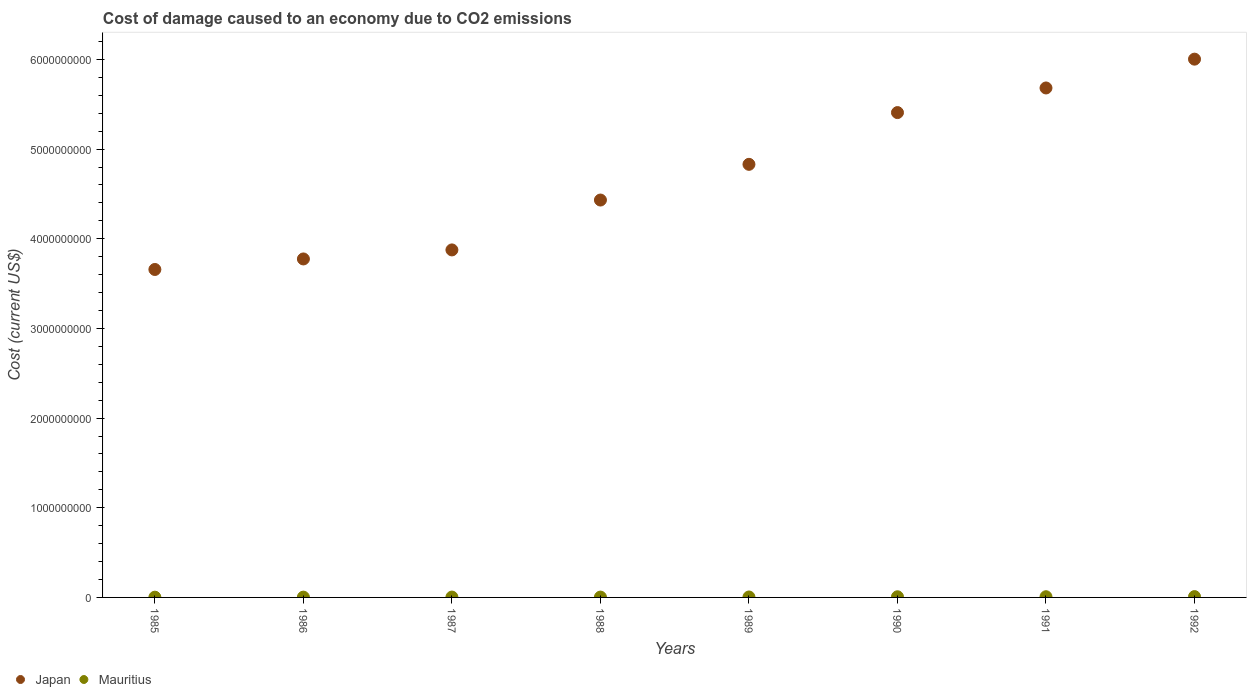How many different coloured dotlines are there?
Offer a very short reply. 2. Is the number of dotlines equal to the number of legend labels?
Your answer should be very brief. Yes. What is the cost of damage caused due to CO2 emissisons in Japan in 1990?
Give a very brief answer. 5.41e+09. Across all years, what is the maximum cost of damage caused due to CO2 emissisons in Japan?
Your response must be concise. 6.00e+09. Across all years, what is the minimum cost of damage caused due to CO2 emissisons in Japan?
Your answer should be very brief. 3.66e+09. In which year was the cost of damage caused due to CO2 emissisons in Japan minimum?
Provide a succinct answer. 1985. What is the total cost of damage caused due to CO2 emissisons in Japan in the graph?
Ensure brevity in your answer.  3.77e+1. What is the difference between the cost of damage caused due to CO2 emissisons in Japan in 1988 and that in 1991?
Provide a succinct answer. -1.25e+09. What is the difference between the cost of damage caused due to CO2 emissisons in Mauritius in 1992 and the cost of damage caused due to CO2 emissisons in Japan in 1990?
Your answer should be very brief. -5.40e+09. What is the average cost of damage caused due to CO2 emissisons in Mauritius per year?
Offer a terse response. 5.39e+06. In the year 1987, what is the difference between the cost of damage caused due to CO2 emissisons in Japan and cost of damage caused due to CO2 emissisons in Mauritius?
Keep it short and to the point. 3.87e+09. What is the ratio of the cost of damage caused due to CO2 emissisons in Mauritius in 1991 to that in 1992?
Your answer should be compact. 0.86. Is the cost of damage caused due to CO2 emissisons in Mauritius in 1988 less than that in 1991?
Ensure brevity in your answer.  Yes. What is the difference between the highest and the second highest cost of damage caused due to CO2 emissisons in Mauritius?
Offer a terse response. 1.27e+06. What is the difference between the highest and the lowest cost of damage caused due to CO2 emissisons in Japan?
Give a very brief answer. 2.35e+09. Is the sum of the cost of damage caused due to CO2 emissisons in Japan in 1987 and 1990 greater than the maximum cost of damage caused due to CO2 emissisons in Mauritius across all years?
Your response must be concise. Yes. Is the cost of damage caused due to CO2 emissisons in Mauritius strictly greater than the cost of damage caused due to CO2 emissisons in Japan over the years?
Your response must be concise. No. Are the values on the major ticks of Y-axis written in scientific E-notation?
Your answer should be compact. No. Does the graph contain grids?
Your answer should be very brief. No. Where does the legend appear in the graph?
Provide a short and direct response. Bottom left. What is the title of the graph?
Keep it short and to the point. Cost of damage caused to an economy due to CO2 emissions. Does "Latin America(developing only)" appear as one of the legend labels in the graph?
Your answer should be very brief. No. What is the label or title of the Y-axis?
Your response must be concise. Cost (current US$). What is the Cost (current US$) of Japan in 1985?
Provide a short and direct response. 3.66e+09. What is the Cost (current US$) of Mauritius in 1985?
Keep it short and to the point. 2.83e+06. What is the Cost (current US$) of Japan in 1986?
Ensure brevity in your answer.  3.77e+09. What is the Cost (current US$) in Mauritius in 1986?
Give a very brief answer. 3.30e+06. What is the Cost (current US$) of Japan in 1987?
Provide a succinct answer. 3.88e+09. What is the Cost (current US$) in Mauritius in 1987?
Offer a very short reply. 3.99e+06. What is the Cost (current US$) of Japan in 1988?
Provide a succinct answer. 4.43e+09. What is the Cost (current US$) of Mauritius in 1988?
Give a very brief answer. 3.83e+06. What is the Cost (current US$) in Japan in 1989?
Provide a short and direct response. 4.83e+09. What is the Cost (current US$) of Mauritius in 1989?
Make the answer very short. 4.96e+06. What is the Cost (current US$) in Japan in 1990?
Ensure brevity in your answer.  5.41e+09. What is the Cost (current US$) of Mauritius in 1990?
Keep it short and to the point. 7.23e+06. What is the Cost (current US$) in Japan in 1991?
Your answer should be very brief. 5.68e+09. What is the Cost (current US$) of Mauritius in 1991?
Your answer should be very brief. 7.86e+06. What is the Cost (current US$) of Japan in 1992?
Offer a very short reply. 6.00e+09. What is the Cost (current US$) in Mauritius in 1992?
Make the answer very short. 9.13e+06. Across all years, what is the maximum Cost (current US$) in Japan?
Your answer should be compact. 6.00e+09. Across all years, what is the maximum Cost (current US$) of Mauritius?
Offer a terse response. 9.13e+06. Across all years, what is the minimum Cost (current US$) of Japan?
Offer a very short reply. 3.66e+09. Across all years, what is the minimum Cost (current US$) in Mauritius?
Ensure brevity in your answer.  2.83e+06. What is the total Cost (current US$) of Japan in the graph?
Provide a short and direct response. 3.77e+1. What is the total Cost (current US$) of Mauritius in the graph?
Your answer should be compact. 4.31e+07. What is the difference between the Cost (current US$) of Japan in 1985 and that in 1986?
Your answer should be very brief. -1.17e+08. What is the difference between the Cost (current US$) in Mauritius in 1985 and that in 1986?
Ensure brevity in your answer.  -4.69e+05. What is the difference between the Cost (current US$) of Japan in 1985 and that in 1987?
Offer a very short reply. -2.18e+08. What is the difference between the Cost (current US$) of Mauritius in 1985 and that in 1987?
Give a very brief answer. -1.16e+06. What is the difference between the Cost (current US$) of Japan in 1985 and that in 1988?
Your response must be concise. -7.74e+08. What is the difference between the Cost (current US$) in Mauritius in 1985 and that in 1988?
Offer a terse response. -1.00e+06. What is the difference between the Cost (current US$) of Japan in 1985 and that in 1989?
Keep it short and to the point. -1.17e+09. What is the difference between the Cost (current US$) in Mauritius in 1985 and that in 1989?
Ensure brevity in your answer.  -2.13e+06. What is the difference between the Cost (current US$) of Japan in 1985 and that in 1990?
Your answer should be very brief. -1.75e+09. What is the difference between the Cost (current US$) of Mauritius in 1985 and that in 1990?
Provide a succinct answer. -4.40e+06. What is the difference between the Cost (current US$) of Japan in 1985 and that in 1991?
Give a very brief answer. -2.02e+09. What is the difference between the Cost (current US$) of Mauritius in 1985 and that in 1991?
Keep it short and to the point. -5.03e+06. What is the difference between the Cost (current US$) of Japan in 1985 and that in 1992?
Offer a very short reply. -2.35e+09. What is the difference between the Cost (current US$) in Mauritius in 1985 and that in 1992?
Offer a very short reply. -6.31e+06. What is the difference between the Cost (current US$) in Japan in 1986 and that in 1987?
Keep it short and to the point. -1.01e+08. What is the difference between the Cost (current US$) of Mauritius in 1986 and that in 1987?
Offer a very short reply. -6.89e+05. What is the difference between the Cost (current US$) in Japan in 1986 and that in 1988?
Your answer should be compact. -6.57e+08. What is the difference between the Cost (current US$) in Mauritius in 1986 and that in 1988?
Your response must be concise. -5.32e+05. What is the difference between the Cost (current US$) in Japan in 1986 and that in 1989?
Provide a short and direct response. -1.06e+09. What is the difference between the Cost (current US$) in Mauritius in 1986 and that in 1989?
Give a very brief answer. -1.66e+06. What is the difference between the Cost (current US$) of Japan in 1986 and that in 1990?
Offer a terse response. -1.63e+09. What is the difference between the Cost (current US$) in Mauritius in 1986 and that in 1990?
Provide a succinct answer. -3.93e+06. What is the difference between the Cost (current US$) in Japan in 1986 and that in 1991?
Your answer should be compact. -1.91e+09. What is the difference between the Cost (current US$) of Mauritius in 1986 and that in 1991?
Make the answer very short. -4.56e+06. What is the difference between the Cost (current US$) of Japan in 1986 and that in 1992?
Keep it short and to the point. -2.23e+09. What is the difference between the Cost (current US$) in Mauritius in 1986 and that in 1992?
Keep it short and to the point. -5.84e+06. What is the difference between the Cost (current US$) of Japan in 1987 and that in 1988?
Your response must be concise. -5.56e+08. What is the difference between the Cost (current US$) of Mauritius in 1987 and that in 1988?
Your answer should be compact. 1.57e+05. What is the difference between the Cost (current US$) of Japan in 1987 and that in 1989?
Provide a short and direct response. -9.54e+08. What is the difference between the Cost (current US$) of Mauritius in 1987 and that in 1989?
Offer a terse response. -9.71e+05. What is the difference between the Cost (current US$) of Japan in 1987 and that in 1990?
Your answer should be compact. -1.53e+09. What is the difference between the Cost (current US$) of Mauritius in 1987 and that in 1990?
Offer a very short reply. -3.24e+06. What is the difference between the Cost (current US$) in Japan in 1987 and that in 1991?
Your response must be concise. -1.81e+09. What is the difference between the Cost (current US$) of Mauritius in 1987 and that in 1991?
Offer a terse response. -3.88e+06. What is the difference between the Cost (current US$) of Japan in 1987 and that in 1992?
Ensure brevity in your answer.  -2.13e+09. What is the difference between the Cost (current US$) of Mauritius in 1987 and that in 1992?
Give a very brief answer. -5.15e+06. What is the difference between the Cost (current US$) of Japan in 1988 and that in 1989?
Your answer should be very brief. -3.98e+08. What is the difference between the Cost (current US$) of Mauritius in 1988 and that in 1989?
Provide a short and direct response. -1.13e+06. What is the difference between the Cost (current US$) of Japan in 1988 and that in 1990?
Ensure brevity in your answer.  -9.75e+08. What is the difference between the Cost (current US$) of Mauritius in 1988 and that in 1990?
Ensure brevity in your answer.  -3.40e+06. What is the difference between the Cost (current US$) of Japan in 1988 and that in 1991?
Provide a succinct answer. -1.25e+09. What is the difference between the Cost (current US$) in Mauritius in 1988 and that in 1991?
Make the answer very short. -4.03e+06. What is the difference between the Cost (current US$) of Japan in 1988 and that in 1992?
Provide a succinct answer. -1.57e+09. What is the difference between the Cost (current US$) of Mauritius in 1988 and that in 1992?
Keep it short and to the point. -5.31e+06. What is the difference between the Cost (current US$) of Japan in 1989 and that in 1990?
Give a very brief answer. -5.77e+08. What is the difference between the Cost (current US$) of Mauritius in 1989 and that in 1990?
Provide a short and direct response. -2.27e+06. What is the difference between the Cost (current US$) in Japan in 1989 and that in 1991?
Your response must be concise. -8.52e+08. What is the difference between the Cost (current US$) of Mauritius in 1989 and that in 1991?
Make the answer very short. -2.90e+06. What is the difference between the Cost (current US$) of Japan in 1989 and that in 1992?
Give a very brief answer. -1.17e+09. What is the difference between the Cost (current US$) of Mauritius in 1989 and that in 1992?
Offer a very short reply. -4.18e+06. What is the difference between the Cost (current US$) of Japan in 1990 and that in 1991?
Your answer should be very brief. -2.75e+08. What is the difference between the Cost (current US$) of Mauritius in 1990 and that in 1991?
Offer a very short reply. -6.32e+05. What is the difference between the Cost (current US$) in Japan in 1990 and that in 1992?
Make the answer very short. -5.96e+08. What is the difference between the Cost (current US$) of Mauritius in 1990 and that in 1992?
Keep it short and to the point. -1.90e+06. What is the difference between the Cost (current US$) of Japan in 1991 and that in 1992?
Your answer should be compact. -3.21e+08. What is the difference between the Cost (current US$) of Mauritius in 1991 and that in 1992?
Your response must be concise. -1.27e+06. What is the difference between the Cost (current US$) in Japan in 1985 and the Cost (current US$) in Mauritius in 1986?
Your answer should be compact. 3.65e+09. What is the difference between the Cost (current US$) of Japan in 1985 and the Cost (current US$) of Mauritius in 1987?
Your answer should be very brief. 3.65e+09. What is the difference between the Cost (current US$) of Japan in 1985 and the Cost (current US$) of Mauritius in 1988?
Provide a succinct answer. 3.65e+09. What is the difference between the Cost (current US$) in Japan in 1985 and the Cost (current US$) in Mauritius in 1989?
Provide a short and direct response. 3.65e+09. What is the difference between the Cost (current US$) in Japan in 1985 and the Cost (current US$) in Mauritius in 1990?
Give a very brief answer. 3.65e+09. What is the difference between the Cost (current US$) in Japan in 1985 and the Cost (current US$) in Mauritius in 1991?
Keep it short and to the point. 3.65e+09. What is the difference between the Cost (current US$) in Japan in 1985 and the Cost (current US$) in Mauritius in 1992?
Keep it short and to the point. 3.65e+09. What is the difference between the Cost (current US$) of Japan in 1986 and the Cost (current US$) of Mauritius in 1987?
Provide a short and direct response. 3.77e+09. What is the difference between the Cost (current US$) of Japan in 1986 and the Cost (current US$) of Mauritius in 1988?
Provide a succinct answer. 3.77e+09. What is the difference between the Cost (current US$) of Japan in 1986 and the Cost (current US$) of Mauritius in 1989?
Ensure brevity in your answer.  3.77e+09. What is the difference between the Cost (current US$) of Japan in 1986 and the Cost (current US$) of Mauritius in 1990?
Ensure brevity in your answer.  3.77e+09. What is the difference between the Cost (current US$) in Japan in 1986 and the Cost (current US$) in Mauritius in 1991?
Offer a very short reply. 3.77e+09. What is the difference between the Cost (current US$) of Japan in 1986 and the Cost (current US$) of Mauritius in 1992?
Provide a succinct answer. 3.77e+09. What is the difference between the Cost (current US$) of Japan in 1987 and the Cost (current US$) of Mauritius in 1988?
Ensure brevity in your answer.  3.87e+09. What is the difference between the Cost (current US$) of Japan in 1987 and the Cost (current US$) of Mauritius in 1989?
Keep it short and to the point. 3.87e+09. What is the difference between the Cost (current US$) of Japan in 1987 and the Cost (current US$) of Mauritius in 1990?
Keep it short and to the point. 3.87e+09. What is the difference between the Cost (current US$) in Japan in 1987 and the Cost (current US$) in Mauritius in 1991?
Offer a terse response. 3.87e+09. What is the difference between the Cost (current US$) in Japan in 1987 and the Cost (current US$) in Mauritius in 1992?
Your answer should be compact. 3.87e+09. What is the difference between the Cost (current US$) of Japan in 1988 and the Cost (current US$) of Mauritius in 1989?
Provide a short and direct response. 4.43e+09. What is the difference between the Cost (current US$) in Japan in 1988 and the Cost (current US$) in Mauritius in 1990?
Your answer should be compact. 4.42e+09. What is the difference between the Cost (current US$) in Japan in 1988 and the Cost (current US$) in Mauritius in 1991?
Give a very brief answer. 4.42e+09. What is the difference between the Cost (current US$) in Japan in 1988 and the Cost (current US$) in Mauritius in 1992?
Offer a terse response. 4.42e+09. What is the difference between the Cost (current US$) of Japan in 1989 and the Cost (current US$) of Mauritius in 1990?
Provide a succinct answer. 4.82e+09. What is the difference between the Cost (current US$) in Japan in 1989 and the Cost (current US$) in Mauritius in 1991?
Ensure brevity in your answer.  4.82e+09. What is the difference between the Cost (current US$) in Japan in 1989 and the Cost (current US$) in Mauritius in 1992?
Ensure brevity in your answer.  4.82e+09. What is the difference between the Cost (current US$) in Japan in 1990 and the Cost (current US$) in Mauritius in 1991?
Offer a terse response. 5.40e+09. What is the difference between the Cost (current US$) in Japan in 1990 and the Cost (current US$) in Mauritius in 1992?
Offer a very short reply. 5.40e+09. What is the difference between the Cost (current US$) of Japan in 1991 and the Cost (current US$) of Mauritius in 1992?
Offer a terse response. 5.67e+09. What is the average Cost (current US$) in Japan per year?
Your answer should be compact. 4.71e+09. What is the average Cost (current US$) of Mauritius per year?
Give a very brief answer. 5.39e+06. In the year 1985, what is the difference between the Cost (current US$) of Japan and Cost (current US$) of Mauritius?
Your answer should be compact. 3.65e+09. In the year 1986, what is the difference between the Cost (current US$) of Japan and Cost (current US$) of Mauritius?
Offer a very short reply. 3.77e+09. In the year 1987, what is the difference between the Cost (current US$) in Japan and Cost (current US$) in Mauritius?
Your answer should be compact. 3.87e+09. In the year 1988, what is the difference between the Cost (current US$) in Japan and Cost (current US$) in Mauritius?
Make the answer very short. 4.43e+09. In the year 1989, what is the difference between the Cost (current US$) of Japan and Cost (current US$) of Mauritius?
Give a very brief answer. 4.83e+09. In the year 1990, what is the difference between the Cost (current US$) in Japan and Cost (current US$) in Mauritius?
Keep it short and to the point. 5.40e+09. In the year 1991, what is the difference between the Cost (current US$) of Japan and Cost (current US$) of Mauritius?
Offer a very short reply. 5.67e+09. In the year 1992, what is the difference between the Cost (current US$) in Japan and Cost (current US$) in Mauritius?
Your response must be concise. 5.99e+09. What is the ratio of the Cost (current US$) of Japan in 1985 to that in 1986?
Provide a succinct answer. 0.97. What is the ratio of the Cost (current US$) of Mauritius in 1985 to that in 1986?
Give a very brief answer. 0.86. What is the ratio of the Cost (current US$) in Japan in 1985 to that in 1987?
Offer a very short reply. 0.94. What is the ratio of the Cost (current US$) in Mauritius in 1985 to that in 1987?
Ensure brevity in your answer.  0.71. What is the ratio of the Cost (current US$) of Japan in 1985 to that in 1988?
Give a very brief answer. 0.83. What is the ratio of the Cost (current US$) in Mauritius in 1985 to that in 1988?
Ensure brevity in your answer.  0.74. What is the ratio of the Cost (current US$) of Japan in 1985 to that in 1989?
Ensure brevity in your answer.  0.76. What is the ratio of the Cost (current US$) of Mauritius in 1985 to that in 1989?
Make the answer very short. 0.57. What is the ratio of the Cost (current US$) in Japan in 1985 to that in 1990?
Your answer should be compact. 0.68. What is the ratio of the Cost (current US$) in Mauritius in 1985 to that in 1990?
Your response must be concise. 0.39. What is the ratio of the Cost (current US$) of Japan in 1985 to that in 1991?
Your answer should be very brief. 0.64. What is the ratio of the Cost (current US$) in Mauritius in 1985 to that in 1991?
Provide a succinct answer. 0.36. What is the ratio of the Cost (current US$) of Japan in 1985 to that in 1992?
Ensure brevity in your answer.  0.61. What is the ratio of the Cost (current US$) in Mauritius in 1985 to that in 1992?
Your answer should be compact. 0.31. What is the ratio of the Cost (current US$) in Mauritius in 1986 to that in 1987?
Give a very brief answer. 0.83. What is the ratio of the Cost (current US$) in Japan in 1986 to that in 1988?
Ensure brevity in your answer.  0.85. What is the ratio of the Cost (current US$) in Mauritius in 1986 to that in 1988?
Provide a succinct answer. 0.86. What is the ratio of the Cost (current US$) of Japan in 1986 to that in 1989?
Keep it short and to the point. 0.78. What is the ratio of the Cost (current US$) of Mauritius in 1986 to that in 1989?
Your answer should be very brief. 0.67. What is the ratio of the Cost (current US$) of Japan in 1986 to that in 1990?
Provide a succinct answer. 0.7. What is the ratio of the Cost (current US$) in Mauritius in 1986 to that in 1990?
Ensure brevity in your answer.  0.46. What is the ratio of the Cost (current US$) in Japan in 1986 to that in 1991?
Give a very brief answer. 0.66. What is the ratio of the Cost (current US$) of Mauritius in 1986 to that in 1991?
Keep it short and to the point. 0.42. What is the ratio of the Cost (current US$) of Japan in 1986 to that in 1992?
Offer a very short reply. 0.63. What is the ratio of the Cost (current US$) in Mauritius in 1986 to that in 1992?
Your response must be concise. 0.36. What is the ratio of the Cost (current US$) in Japan in 1987 to that in 1988?
Make the answer very short. 0.87. What is the ratio of the Cost (current US$) in Mauritius in 1987 to that in 1988?
Keep it short and to the point. 1.04. What is the ratio of the Cost (current US$) of Japan in 1987 to that in 1989?
Your response must be concise. 0.8. What is the ratio of the Cost (current US$) of Mauritius in 1987 to that in 1989?
Your answer should be very brief. 0.8. What is the ratio of the Cost (current US$) in Japan in 1987 to that in 1990?
Make the answer very short. 0.72. What is the ratio of the Cost (current US$) in Mauritius in 1987 to that in 1990?
Ensure brevity in your answer.  0.55. What is the ratio of the Cost (current US$) in Japan in 1987 to that in 1991?
Ensure brevity in your answer.  0.68. What is the ratio of the Cost (current US$) of Mauritius in 1987 to that in 1991?
Provide a succinct answer. 0.51. What is the ratio of the Cost (current US$) of Japan in 1987 to that in 1992?
Provide a short and direct response. 0.65. What is the ratio of the Cost (current US$) of Mauritius in 1987 to that in 1992?
Ensure brevity in your answer.  0.44. What is the ratio of the Cost (current US$) in Japan in 1988 to that in 1989?
Offer a very short reply. 0.92. What is the ratio of the Cost (current US$) in Mauritius in 1988 to that in 1989?
Offer a terse response. 0.77. What is the ratio of the Cost (current US$) in Japan in 1988 to that in 1990?
Keep it short and to the point. 0.82. What is the ratio of the Cost (current US$) of Mauritius in 1988 to that in 1990?
Offer a terse response. 0.53. What is the ratio of the Cost (current US$) in Japan in 1988 to that in 1991?
Make the answer very short. 0.78. What is the ratio of the Cost (current US$) of Mauritius in 1988 to that in 1991?
Make the answer very short. 0.49. What is the ratio of the Cost (current US$) of Japan in 1988 to that in 1992?
Ensure brevity in your answer.  0.74. What is the ratio of the Cost (current US$) in Mauritius in 1988 to that in 1992?
Provide a succinct answer. 0.42. What is the ratio of the Cost (current US$) in Japan in 1989 to that in 1990?
Give a very brief answer. 0.89. What is the ratio of the Cost (current US$) of Mauritius in 1989 to that in 1990?
Give a very brief answer. 0.69. What is the ratio of the Cost (current US$) in Japan in 1989 to that in 1991?
Make the answer very short. 0.85. What is the ratio of the Cost (current US$) in Mauritius in 1989 to that in 1991?
Offer a very short reply. 0.63. What is the ratio of the Cost (current US$) in Japan in 1989 to that in 1992?
Keep it short and to the point. 0.8. What is the ratio of the Cost (current US$) in Mauritius in 1989 to that in 1992?
Ensure brevity in your answer.  0.54. What is the ratio of the Cost (current US$) in Japan in 1990 to that in 1991?
Ensure brevity in your answer.  0.95. What is the ratio of the Cost (current US$) in Mauritius in 1990 to that in 1991?
Ensure brevity in your answer.  0.92. What is the ratio of the Cost (current US$) of Japan in 1990 to that in 1992?
Your response must be concise. 0.9. What is the ratio of the Cost (current US$) of Mauritius in 1990 to that in 1992?
Your answer should be very brief. 0.79. What is the ratio of the Cost (current US$) in Japan in 1991 to that in 1992?
Provide a succinct answer. 0.95. What is the ratio of the Cost (current US$) of Mauritius in 1991 to that in 1992?
Your answer should be compact. 0.86. What is the difference between the highest and the second highest Cost (current US$) in Japan?
Make the answer very short. 3.21e+08. What is the difference between the highest and the second highest Cost (current US$) of Mauritius?
Provide a short and direct response. 1.27e+06. What is the difference between the highest and the lowest Cost (current US$) of Japan?
Offer a very short reply. 2.35e+09. What is the difference between the highest and the lowest Cost (current US$) in Mauritius?
Your answer should be very brief. 6.31e+06. 